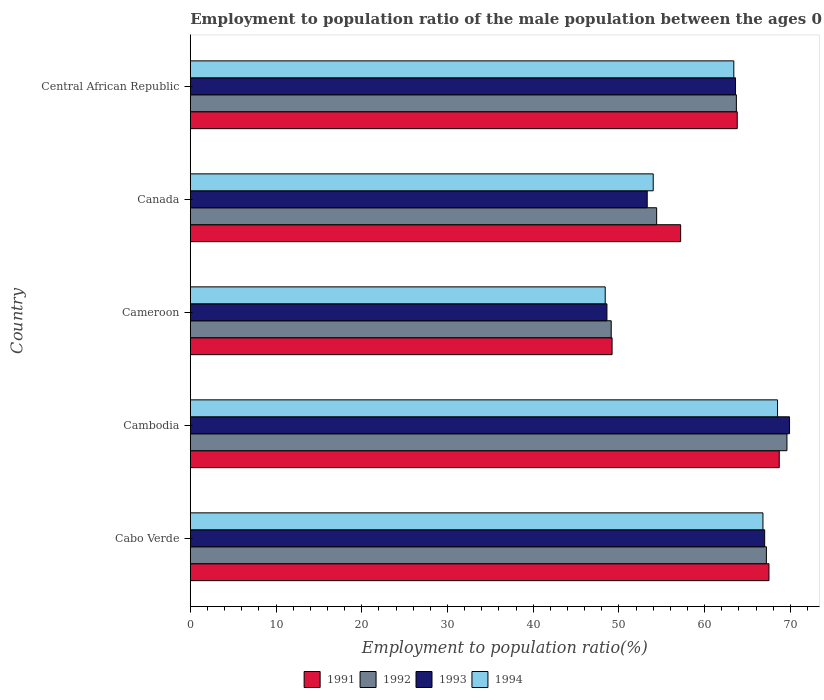How many groups of bars are there?
Offer a terse response. 5. Are the number of bars per tick equal to the number of legend labels?
Ensure brevity in your answer.  Yes. Are the number of bars on each tick of the Y-axis equal?
Offer a terse response. Yes. How many bars are there on the 2nd tick from the bottom?
Offer a terse response. 4. What is the label of the 1st group of bars from the top?
Provide a succinct answer. Central African Republic. What is the employment to population ratio in 1993 in Cambodia?
Your response must be concise. 69.9. Across all countries, what is the maximum employment to population ratio in 1994?
Offer a very short reply. 68.5. Across all countries, what is the minimum employment to population ratio in 1992?
Make the answer very short. 49.1. In which country was the employment to population ratio in 1993 maximum?
Provide a succinct answer. Cambodia. In which country was the employment to population ratio in 1991 minimum?
Ensure brevity in your answer.  Cameroon. What is the total employment to population ratio in 1993 in the graph?
Your answer should be very brief. 302.4. What is the difference between the employment to population ratio in 1992 in Cambodia and that in Central African Republic?
Offer a very short reply. 5.9. What is the difference between the employment to population ratio in 1993 in Cameroon and the employment to population ratio in 1992 in Canada?
Offer a very short reply. -5.8. What is the average employment to population ratio in 1993 per country?
Offer a terse response. 60.48. What is the difference between the employment to population ratio in 1994 and employment to population ratio in 1992 in Central African Republic?
Provide a succinct answer. -0.3. What is the ratio of the employment to population ratio in 1994 in Cambodia to that in Cameroon?
Make the answer very short. 1.42. What is the difference between the highest and the second highest employment to population ratio in 1993?
Provide a short and direct response. 2.9. What is the difference between the highest and the lowest employment to population ratio in 1992?
Offer a terse response. 20.5. Is it the case that in every country, the sum of the employment to population ratio in 1994 and employment to population ratio in 1991 is greater than the sum of employment to population ratio in 1992 and employment to population ratio in 1993?
Your response must be concise. No. What does the 2nd bar from the top in Cameroon represents?
Ensure brevity in your answer.  1993. How many bars are there?
Your response must be concise. 20. Are all the bars in the graph horizontal?
Make the answer very short. Yes. How many countries are there in the graph?
Offer a very short reply. 5. What is the difference between two consecutive major ticks on the X-axis?
Provide a short and direct response. 10. Are the values on the major ticks of X-axis written in scientific E-notation?
Give a very brief answer. No. Where does the legend appear in the graph?
Provide a short and direct response. Bottom center. How many legend labels are there?
Your response must be concise. 4. What is the title of the graph?
Offer a terse response. Employment to population ratio of the male population between the ages 0 to 14. What is the label or title of the Y-axis?
Ensure brevity in your answer.  Country. What is the Employment to population ratio(%) of 1991 in Cabo Verde?
Ensure brevity in your answer.  67.5. What is the Employment to population ratio(%) of 1992 in Cabo Verde?
Keep it short and to the point. 67.2. What is the Employment to population ratio(%) in 1994 in Cabo Verde?
Give a very brief answer. 66.8. What is the Employment to population ratio(%) in 1991 in Cambodia?
Ensure brevity in your answer.  68.7. What is the Employment to population ratio(%) of 1992 in Cambodia?
Ensure brevity in your answer.  69.6. What is the Employment to population ratio(%) of 1993 in Cambodia?
Offer a terse response. 69.9. What is the Employment to population ratio(%) of 1994 in Cambodia?
Make the answer very short. 68.5. What is the Employment to population ratio(%) of 1991 in Cameroon?
Your answer should be compact. 49.2. What is the Employment to population ratio(%) in 1992 in Cameroon?
Offer a terse response. 49.1. What is the Employment to population ratio(%) in 1993 in Cameroon?
Offer a terse response. 48.6. What is the Employment to population ratio(%) of 1994 in Cameroon?
Your response must be concise. 48.4. What is the Employment to population ratio(%) of 1991 in Canada?
Offer a very short reply. 57.2. What is the Employment to population ratio(%) of 1992 in Canada?
Keep it short and to the point. 54.4. What is the Employment to population ratio(%) of 1993 in Canada?
Ensure brevity in your answer.  53.3. What is the Employment to population ratio(%) of 1991 in Central African Republic?
Ensure brevity in your answer.  63.8. What is the Employment to population ratio(%) in 1992 in Central African Republic?
Provide a succinct answer. 63.7. What is the Employment to population ratio(%) of 1993 in Central African Republic?
Offer a terse response. 63.6. What is the Employment to population ratio(%) in 1994 in Central African Republic?
Make the answer very short. 63.4. Across all countries, what is the maximum Employment to population ratio(%) of 1991?
Give a very brief answer. 68.7. Across all countries, what is the maximum Employment to population ratio(%) of 1992?
Offer a very short reply. 69.6. Across all countries, what is the maximum Employment to population ratio(%) in 1993?
Your response must be concise. 69.9. Across all countries, what is the maximum Employment to population ratio(%) in 1994?
Make the answer very short. 68.5. Across all countries, what is the minimum Employment to population ratio(%) of 1991?
Make the answer very short. 49.2. Across all countries, what is the minimum Employment to population ratio(%) of 1992?
Ensure brevity in your answer.  49.1. Across all countries, what is the minimum Employment to population ratio(%) in 1993?
Provide a succinct answer. 48.6. Across all countries, what is the minimum Employment to population ratio(%) of 1994?
Offer a terse response. 48.4. What is the total Employment to population ratio(%) in 1991 in the graph?
Make the answer very short. 306.4. What is the total Employment to population ratio(%) in 1992 in the graph?
Give a very brief answer. 304. What is the total Employment to population ratio(%) of 1993 in the graph?
Make the answer very short. 302.4. What is the total Employment to population ratio(%) of 1994 in the graph?
Give a very brief answer. 301.1. What is the difference between the Employment to population ratio(%) of 1992 in Cabo Verde and that in Cambodia?
Offer a terse response. -2.4. What is the difference between the Employment to population ratio(%) of 1991 in Cabo Verde and that in Cameroon?
Your response must be concise. 18.3. What is the difference between the Employment to population ratio(%) in 1992 in Cabo Verde and that in Cameroon?
Your answer should be very brief. 18.1. What is the difference between the Employment to population ratio(%) in 1993 in Cabo Verde and that in Cameroon?
Your answer should be compact. 18.4. What is the difference between the Employment to population ratio(%) in 1991 in Cabo Verde and that in Canada?
Offer a very short reply. 10.3. What is the difference between the Employment to population ratio(%) of 1992 in Cabo Verde and that in Canada?
Offer a terse response. 12.8. What is the difference between the Employment to population ratio(%) in 1994 in Cabo Verde and that in Canada?
Offer a terse response. 12.8. What is the difference between the Employment to population ratio(%) of 1991 in Cabo Verde and that in Central African Republic?
Offer a terse response. 3.7. What is the difference between the Employment to population ratio(%) in 1992 in Cabo Verde and that in Central African Republic?
Offer a very short reply. 3.5. What is the difference between the Employment to population ratio(%) of 1994 in Cabo Verde and that in Central African Republic?
Your response must be concise. 3.4. What is the difference between the Employment to population ratio(%) of 1992 in Cambodia and that in Cameroon?
Your answer should be very brief. 20.5. What is the difference between the Employment to population ratio(%) of 1993 in Cambodia and that in Cameroon?
Your answer should be very brief. 21.3. What is the difference between the Employment to population ratio(%) in 1994 in Cambodia and that in Cameroon?
Give a very brief answer. 20.1. What is the difference between the Employment to population ratio(%) of 1991 in Cambodia and that in Canada?
Ensure brevity in your answer.  11.5. What is the difference between the Employment to population ratio(%) in 1992 in Cambodia and that in Canada?
Ensure brevity in your answer.  15.2. What is the difference between the Employment to population ratio(%) of 1993 in Cambodia and that in Canada?
Offer a terse response. 16.6. What is the difference between the Employment to population ratio(%) in 1994 in Cambodia and that in Canada?
Your answer should be compact. 14.5. What is the difference between the Employment to population ratio(%) in 1994 in Cambodia and that in Central African Republic?
Give a very brief answer. 5.1. What is the difference between the Employment to population ratio(%) of 1991 in Cameroon and that in Canada?
Keep it short and to the point. -8. What is the difference between the Employment to population ratio(%) of 1993 in Cameroon and that in Canada?
Offer a terse response. -4.7. What is the difference between the Employment to population ratio(%) in 1994 in Cameroon and that in Canada?
Give a very brief answer. -5.6. What is the difference between the Employment to population ratio(%) in 1991 in Cameroon and that in Central African Republic?
Keep it short and to the point. -14.6. What is the difference between the Employment to population ratio(%) of 1992 in Cameroon and that in Central African Republic?
Offer a terse response. -14.6. What is the difference between the Employment to population ratio(%) of 1993 in Cameroon and that in Central African Republic?
Your answer should be very brief. -15. What is the difference between the Employment to population ratio(%) of 1994 in Cameroon and that in Central African Republic?
Provide a short and direct response. -15. What is the difference between the Employment to population ratio(%) of 1991 in Canada and that in Central African Republic?
Give a very brief answer. -6.6. What is the difference between the Employment to population ratio(%) of 1992 in Canada and that in Central African Republic?
Make the answer very short. -9.3. What is the difference between the Employment to population ratio(%) of 1992 in Cabo Verde and the Employment to population ratio(%) of 1993 in Cameroon?
Ensure brevity in your answer.  18.6. What is the difference between the Employment to population ratio(%) in 1992 in Cabo Verde and the Employment to population ratio(%) in 1994 in Cameroon?
Give a very brief answer. 18.8. What is the difference between the Employment to population ratio(%) in 1991 in Cabo Verde and the Employment to population ratio(%) in 1992 in Canada?
Your answer should be very brief. 13.1. What is the difference between the Employment to population ratio(%) in 1991 in Cabo Verde and the Employment to population ratio(%) in 1994 in Canada?
Make the answer very short. 13.5. What is the difference between the Employment to population ratio(%) in 1991 in Cabo Verde and the Employment to population ratio(%) in 1992 in Central African Republic?
Provide a succinct answer. 3.8. What is the difference between the Employment to population ratio(%) in 1992 in Cabo Verde and the Employment to population ratio(%) in 1994 in Central African Republic?
Offer a very short reply. 3.8. What is the difference between the Employment to population ratio(%) in 1993 in Cabo Verde and the Employment to population ratio(%) in 1994 in Central African Republic?
Your answer should be very brief. 3.6. What is the difference between the Employment to population ratio(%) of 1991 in Cambodia and the Employment to population ratio(%) of 1992 in Cameroon?
Give a very brief answer. 19.6. What is the difference between the Employment to population ratio(%) in 1991 in Cambodia and the Employment to population ratio(%) in 1993 in Cameroon?
Your answer should be very brief. 20.1. What is the difference between the Employment to population ratio(%) in 1991 in Cambodia and the Employment to population ratio(%) in 1994 in Cameroon?
Provide a short and direct response. 20.3. What is the difference between the Employment to population ratio(%) in 1992 in Cambodia and the Employment to population ratio(%) in 1994 in Cameroon?
Your answer should be very brief. 21.2. What is the difference between the Employment to population ratio(%) in 1991 in Cambodia and the Employment to population ratio(%) in 1992 in Canada?
Keep it short and to the point. 14.3. What is the difference between the Employment to population ratio(%) of 1991 in Cambodia and the Employment to population ratio(%) of 1993 in Canada?
Ensure brevity in your answer.  15.4. What is the difference between the Employment to population ratio(%) in 1991 in Cambodia and the Employment to population ratio(%) in 1994 in Canada?
Your answer should be compact. 14.7. What is the difference between the Employment to population ratio(%) of 1993 in Cambodia and the Employment to population ratio(%) of 1994 in Canada?
Your answer should be very brief. 15.9. What is the difference between the Employment to population ratio(%) in 1991 in Cambodia and the Employment to population ratio(%) in 1992 in Central African Republic?
Keep it short and to the point. 5. What is the difference between the Employment to population ratio(%) of 1991 in Cambodia and the Employment to population ratio(%) of 1993 in Central African Republic?
Your response must be concise. 5.1. What is the difference between the Employment to population ratio(%) in 1992 in Cambodia and the Employment to population ratio(%) in 1994 in Central African Republic?
Ensure brevity in your answer.  6.2. What is the difference between the Employment to population ratio(%) of 1991 in Cameroon and the Employment to population ratio(%) of 1992 in Canada?
Your answer should be very brief. -5.2. What is the difference between the Employment to population ratio(%) of 1991 in Cameroon and the Employment to population ratio(%) of 1994 in Canada?
Make the answer very short. -4.8. What is the difference between the Employment to population ratio(%) in 1992 in Cameroon and the Employment to population ratio(%) in 1993 in Canada?
Provide a succinct answer. -4.2. What is the difference between the Employment to population ratio(%) in 1993 in Cameroon and the Employment to population ratio(%) in 1994 in Canada?
Offer a terse response. -5.4. What is the difference between the Employment to population ratio(%) in 1991 in Cameroon and the Employment to population ratio(%) in 1992 in Central African Republic?
Offer a terse response. -14.5. What is the difference between the Employment to population ratio(%) of 1991 in Cameroon and the Employment to population ratio(%) of 1993 in Central African Republic?
Your answer should be very brief. -14.4. What is the difference between the Employment to population ratio(%) in 1992 in Cameroon and the Employment to population ratio(%) in 1993 in Central African Republic?
Keep it short and to the point. -14.5. What is the difference between the Employment to population ratio(%) in 1992 in Cameroon and the Employment to population ratio(%) in 1994 in Central African Republic?
Your response must be concise. -14.3. What is the difference between the Employment to population ratio(%) in 1993 in Cameroon and the Employment to population ratio(%) in 1994 in Central African Republic?
Keep it short and to the point. -14.8. What is the difference between the Employment to population ratio(%) in 1991 in Canada and the Employment to population ratio(%) in 1994 in Central African Republic?
Your response must be concise. -6.2. What is the difference between the Employment to population ratio(%) of 1992 in Canada and the Employment to population ratio(%) of 1993 in Central African Republic?
Your answer should be compact. -9.2. What is the average Employment to population ratio(%) in 1991 per country?
Offer a terse response. 61.28. What is the average Employment to population ratio(%) in 1992 per country?
Your response must be concise. 60.8. What is the average Employment to population ratio(%) in 1993 per country?
Keep it short and to the point. 60.48. What is the average Employment to population ratio(%) of 1994 per country?
Your response must be concise. 60.22. What is the difference between the Employment to population ratio(%) of 1991 and Employment to population ratio(%) of 1993 in Cabo Verde?
Keep it short and to the point. 0.5. What is the difference between the Employment to population ratio(%) of 1991 and Employment to population ratio(%) of 1994 in Cabo Verde?
Make the answer very short. 0.7. What is the difference between the Employment to population ratio(%) in 1992 and Employment to population ratio(%) in 1994 in Cabo Verde?
Provide a short and direct response. 0.4. What is the difference between the Employment to population ratio(%) of 1991 and Employment to population ratio(%) of 1992 in Cambodia?
Ensure brevity in your answer.  -0.9. What is the difference between the Employment to population ratio(%) of 1991 and Employment to population ratio(%) of 1993 in Cambodia?
Your response must be concise. -1.2. What is the difference between the Employment to population ratio(%) of 1991 and Employment to population ratio(%) of 1994 in Cambodia?
Provide a short and direct response. 0.2. What is the difference between the Employment to population ratio(%) of 1992 and Employment to population ratio(%) of 1994 in Cambodia?
Offer a very short reply. 1.1. What is the difference between the Employment to population ratio(%) of 1993 and Employment to population ratio(%) of 1994 in Cambodia?
Ensure brevity in your answer.  1.4. What is the difference between the Employment to population ratio(%) in 1991 and Employment to population ratio(%) in 1993 in Cameroon?
Your answer should be very brief. 0.6. What is the difference between the Employment to population ratio(%) of 1991 and Employment to population ratio(%) of 1994 in Cameroon?
Ensure brevity in your answer.  0.8. What is the difference between the Employment to population ratio(%) of 1992 and Employment to population ratio(%) of 1994 in Cameroon?
Offer a very short reply. 0.7. What is the difference between the Employment to population ratio(%) in 1991 and Employment to population ratio(%) in 1993 in Canada?
Your answer should be very brief. 3.9. What is the difference between the Employment to population ratio(%) in 1991 and Employment to population ratio(%) in 1994 in Canada?
Your response must be concise. 3.2. What is the difference between the Employment to population ratio(%) in 1992 and Employment to population ratio(%) in 1994 in Canada?
Make the answer very short. 0.4. What is the difference between the Employment to population ratio(%) of 1991 and Employment to population ratio(%) of 1992 in Central African Republic?
Give a very brief answer. 0.1. What is the difference between the Employment to population ratio(%) of 1991 and Employment to population ratio(%) of 1993 in Central African Republic?
Give a very brief answer. 0.2. What is the difference between the Employment to population ratio(%) in 1992 and Employment to population ratio(%) in 1994 in Central African Republic?
Provide a succinct answer. 0.3. What is the difference between the Employment to population ratio(%) of 1993 and Employment to population ratio(%) of 1994 in Central African Republic?
Keep it short and to the point. 0.2. What is the ratio of the Employment to population ratio(%) in 1991 in Cabo Verde to that in Cambodia?
Your answer should be very brief. 0.98. What is the ratio of the Employment to population ratio(%) of 1992 in Cabo Verde to that in Cambodia?
Make the answer very short. 0.97. What is the ratio of the Employment to population ratio(%) of 1993 in Cabo Verde to that in Cambodia?
Offer a terse response. 0.96. What is the ratio of the Employment to population ratio(%) in 1994 in Cabo Verde to that in Cambodia?
Your answer should be compact. 0.98. What is the ratio of the Employment to population ratio(%) of 1991 in Cabo Verde to that in Cameroon?
Your answer should be compact. 1.37. What is the ratio of the Employment to population ratio(%) of 1992 in Cabo Verde to that in Cameroon?
Give a very brief answer. 1.37. What is the ratio of the Employment to population ratio(%) of 1993 in Cabo Verde to that in Cameroon?
Provide a short and direct response. 1.38. What is the ratio of the Employment to population ratio(%) of 1994 in Cabo Verde to that in Cameroon?
Give a very brief answer. 1.38. What is the ratio of the Employment to population ratio(%) of 1991 in Cabo Verde to that in Canada?
Your response must be concise. 1.18. What is the ratio of the Employment to population ratio(%) in 1992 in Cabo Verde to that in Canada?
Keep it short and to the point. 1.24. What is the ratio of the Employment to population ratio(%) in 1993 in Cabo Verde to that in Canada?
Your answer should be compact. 1.26. What is the ratio of the Employment to population ratio(%) in 1994 in Cabo Verde to that in Canada?
Ensure brevity in your answer.  1.24. What is the ratio of the Employment to population ratio(%) of 1991 in Cabo Verde to that in Central African Republic?
Offer a very short reply. 1.06. What is the ratio of the Employment to population ratio(%) of 1992 in Cabo Verde to that in Central African Republic?
Make the answer very short. 1.05. What is the ratio of the Employment to population ratio(%) of 1993 in Cabo Verde to that in Central African Republic?
Keep it short and to the point. 1.05. What is the ratio of the Employment to population ratio(%) in 1994 in Cabo Verde to that in Central African Republic?
Your answer should be compact. 1.05. What is the ratio of the Employment to population ratio(%) in 1991 in Cambodia to that in Cameroon?
Your answer should be compact. 1.4. What is the ratio of the Employment to population ratio(%) of 1992 in Cambodia to that in Cameroon?
Your answer should be very brief. 1.42. What is the ratio of the Employment to population ratio(%) in 1993 in Cambodia to that in Cameroon?
Make the answer very short. 1.44. What is the ratio of the Employment to population ratio(%) in 1994 in Cambodia to that in Cameroon?
Offer a terse response. 1.42. What is the ratio of the Employment to population ratio(%) of 1991 in Cambodia to that in Canada?
Offer a very short reply. 1.2. What is the ratio of the Employment to population ratio(%) in 1992 in Cambodia to that in Canada?
Provide a succinct answer. 1.28. What is the ratio of the Employment to population ratio(%) in 1993 in Cambodia to that in Canada?
Your response must be concise. 1.31. What is the ratio of the Employment to population ratio(%) of 1994 in Cambodia to that in Canada?
Make the answer very short. 1.27. What is the ratio of the Employment to population ratio(%) in 1991 in Cambodia to that in Central African Republic?
Your answer should be compact. 1.08. What is the ratio of the Employment to population ratio(%) in 1992 in Cambodia to that in Central African Republic?
Give a very brief answer. 1.09. What is the ratio of the Employment to population ratio(%) of 1993 in Cambodia to that in Central African Republic?
Your answer should be compact. 1.1. What is the ratio of the Employment to population ratio(%) of 1994 in Cambodia to that in Central African Republic?
Your response must be concise. 1.08. What is the ratio of the Employment to population ratio(%) in 1991 in Cameroon to that in Canada?
Provide a succinct answer. 0.86. What is the ratio of the Employment to population ratio(%) of 1992 in Cameroon to that in Canada?
Keep it short and to the point. 0.9. What is the ratio of the Employment to population ratio(%) of 1993 in Cameroon to that in Canada?
Ensure brevity in your answer.  0.91. What is the ratio of the Employment to population ratio(%) of 1994 in Cameroon to that in Canada?
Make the answer very short. 0.9. What is the ratio of the Employment to population ratio(%) of 1991 in Cameroon to that in Central African Republic?
Your answer should be very brief. 0.77. What is the ratio of the Employment to population ratio(%) of 1992 in Cameroon to that in Central African Republic?
Provide a short and direct response. 0.77. What is the ratio of the Employment to population ratio(%) in 1993 in Cameroon to that in Central African Republic?
Provide a short and direct response. 0.76. What is the ratio of the Employment to population ratio(%) in 1994 in Cameroon to that in Central African Republic?
Your answer should be very brief. 0.76. What is the ratio of the Employment to population ratio(%) of 1991 in Canada to that in Central African Republic?
Your answer should be very brief. 0.9. What is the ratio of the Employment to population ratio(%) of 1992 in Canada to that in Central African Republic?
Make the answer very short. 0.85. What is the ratio of the Employment to population ratio(%) in 1993 in Canada to that in Central African Republic?
Your answer should be compact. 0.84. What is the ratio of the Employment to population ratio(%) in 1994 in Canada to that in Central African Republic?
Your answer should be very brief. 0.85. What is the difference between the highest and the second highest Employment to population ratio(%) of 1991?
Keep it short and to the point. 1.2. What is the difference between the highest and the second highest Employment to population ratio(%) of 1992?
Keep it short and to the point. 2.4. What is the difference between the highest and the second highest Employment to population ratio(%) of 1993?
Make the answer very short. 2.9. What is the difference between the highest and the lowest Employment to population ratio(%) of 1993?
Offer a very short reply. 21.3. What is the difference between the highest and the lowest Employment to population ratio(%) in 1994?
Offer a very short reply. 20.1. 